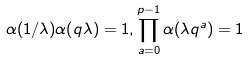<formula> <loc_0><loc_0><loc_500><loc_500>\alpha ( 1 / \lambda ) \alpha ( q \lambda ) = 1 , \prod _ { a = 0 } ^ { p - 1 } \alpha ( \lambda q ^ { a } ) = 1</formula> 